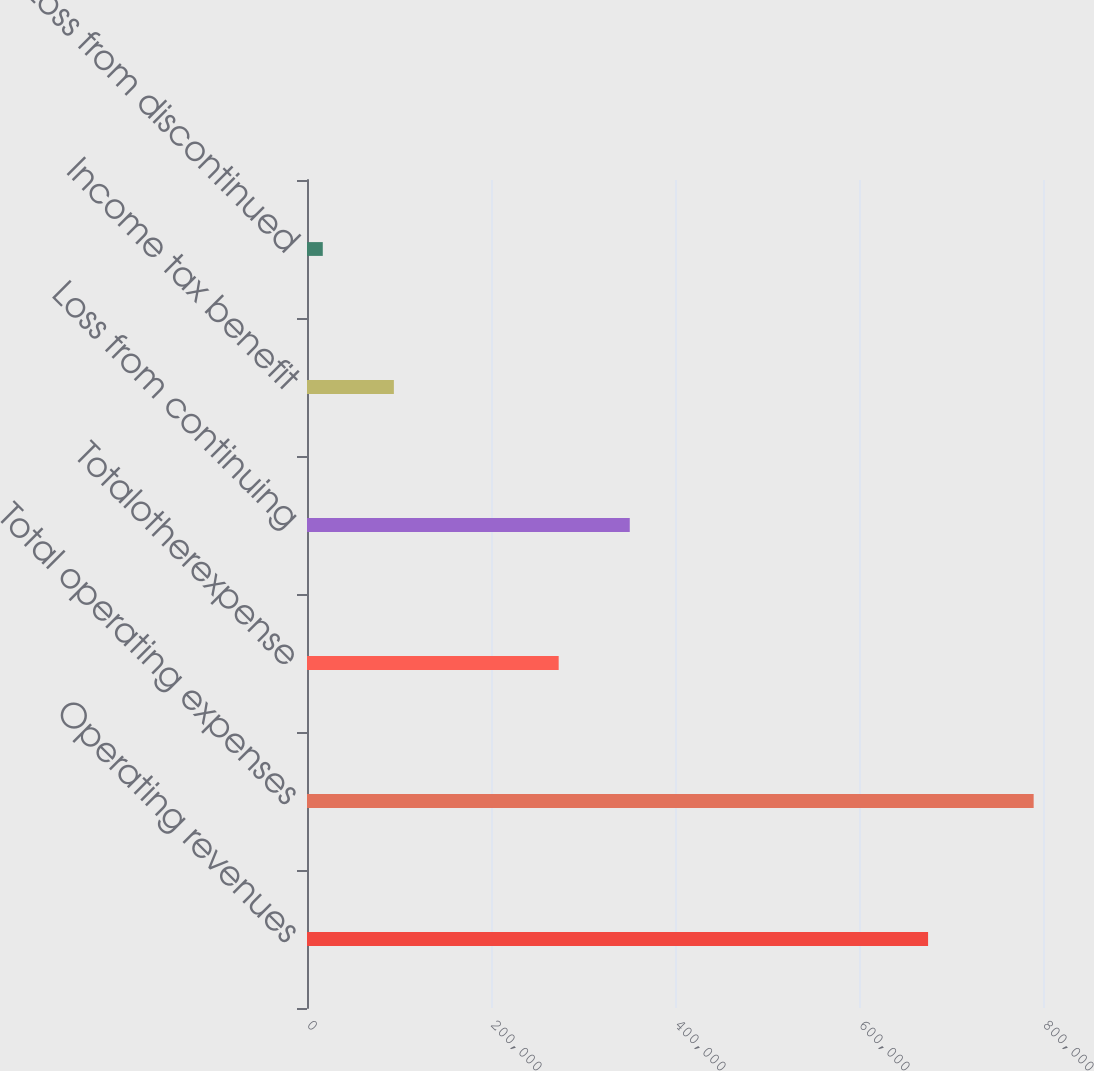Convert chart to OTSL. <chart><loc_0><loc_0><loc_500><loc_500><bar_chart><fcel>Operating revenues<fcel>Total operating expenses<fcel>Totalotherexpense<fcel>Loss from continuing<fcel>Income tax benefit<fcel>Loss from discontinued<nl><fcel>675082<fcel>789844<fcel>273558<fcel>350828<fcel>94418.5<fcel>17149<nl></chart> 